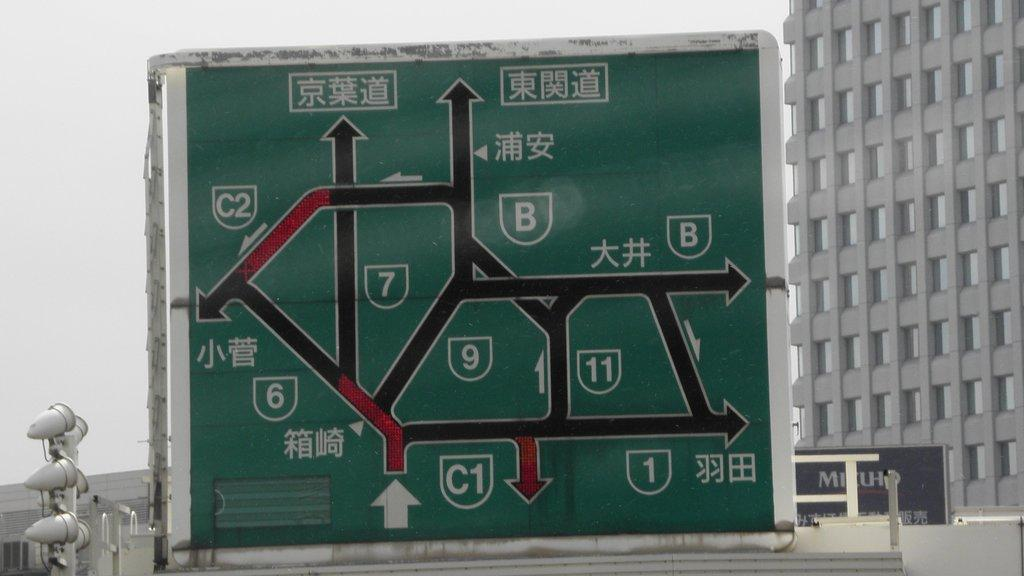<image>
Write a terse but informative summary of the picture. A really complicated road sign has the numbers 1, 6, 7, and 9 on it. 